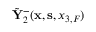Convert formula to latex. <formula><loc_0><loc_0><loc_500><loc_500>\tilde { Y } _ { 2 } ^ { - } ( { x } , { s } , { x _ { 3 , F } } )</formula> 